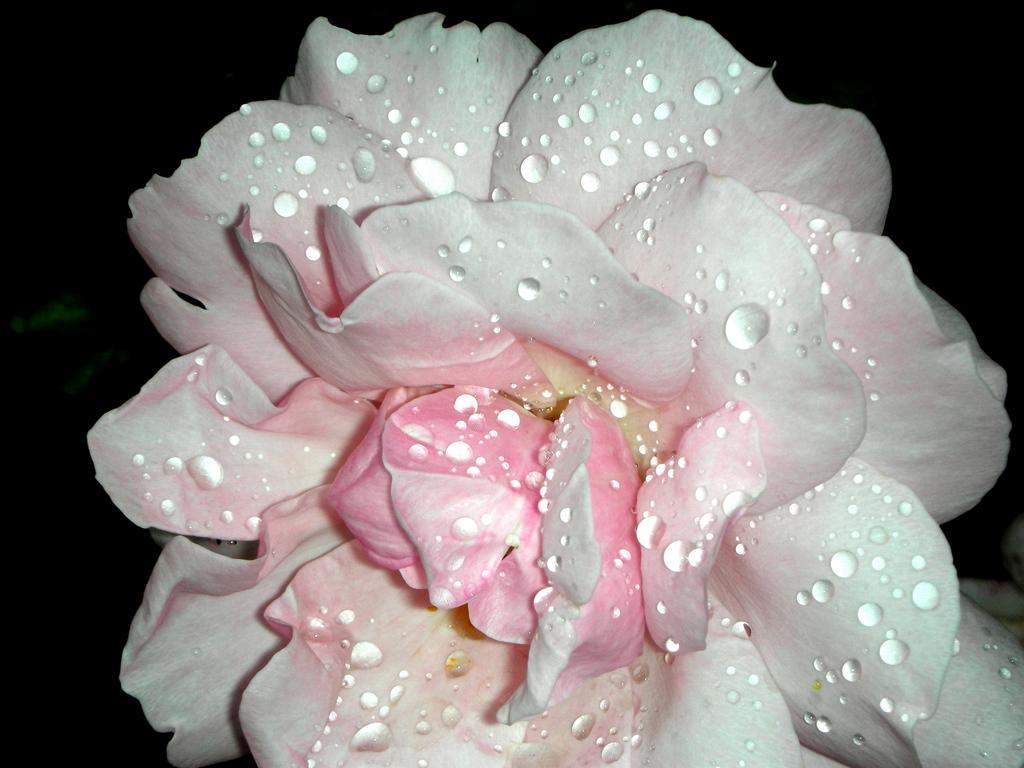Please provide a concise description of this image. In this picture we can see flower, in it we can see some water drops. 